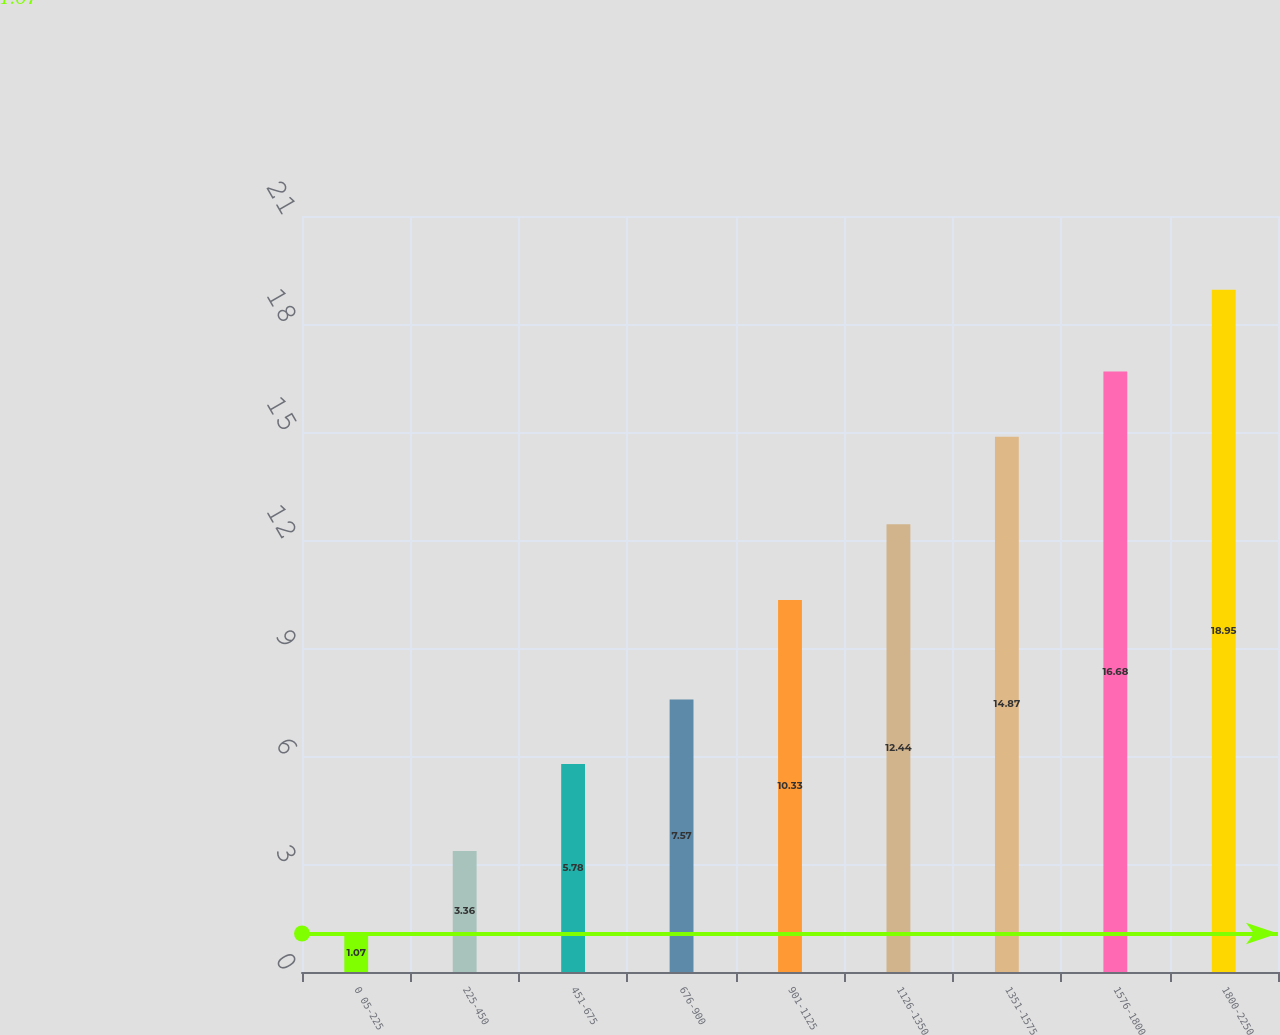<chart> <loc_0><loc_0><loc_500><loc_500><bar_chart><fcel>0 05-225<fcel>225-450<fcel>451-675<fcel>676-900<fcel>901-1125<fcel>1126-1350<fcel>1351-1575<fcel>1576-1800<fcel>1800-2250<nl><fcel>1.07<fcel>3.36<fcel>5.78<fcel>7.57<fcel>10.33<fcel>12.44<fcel>14.87<fcel>16.68<fcel>18.95<nl></chart> 